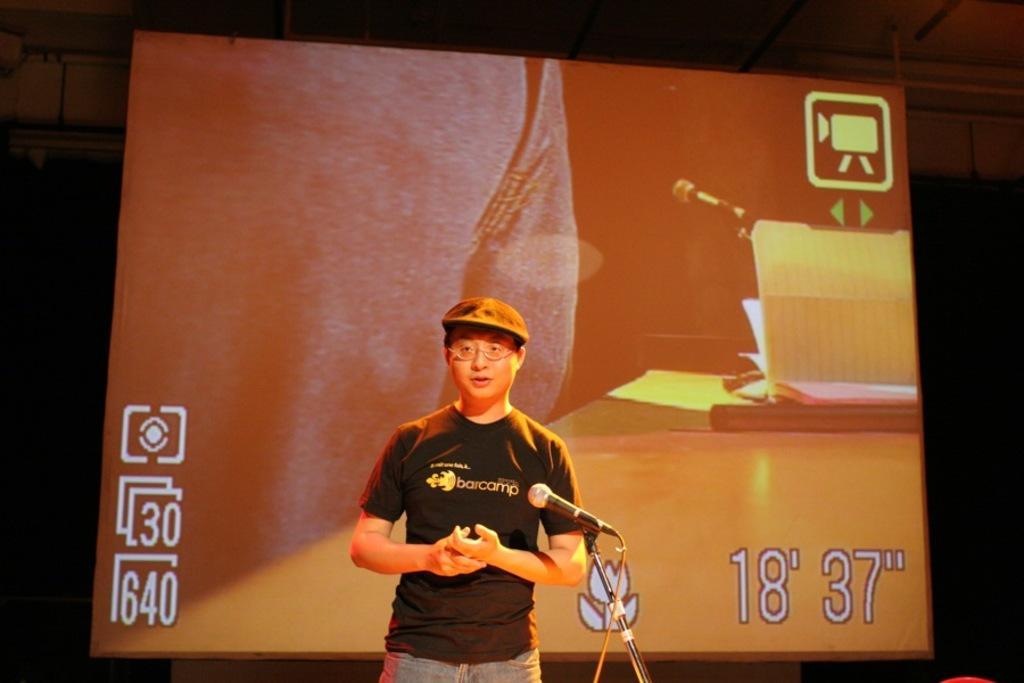Please provide a concise description of this image. In this picture we can see a person, he is wearing a cap and spectacles, in front of him we can see a mic and in the background we can see a screen, roof. 